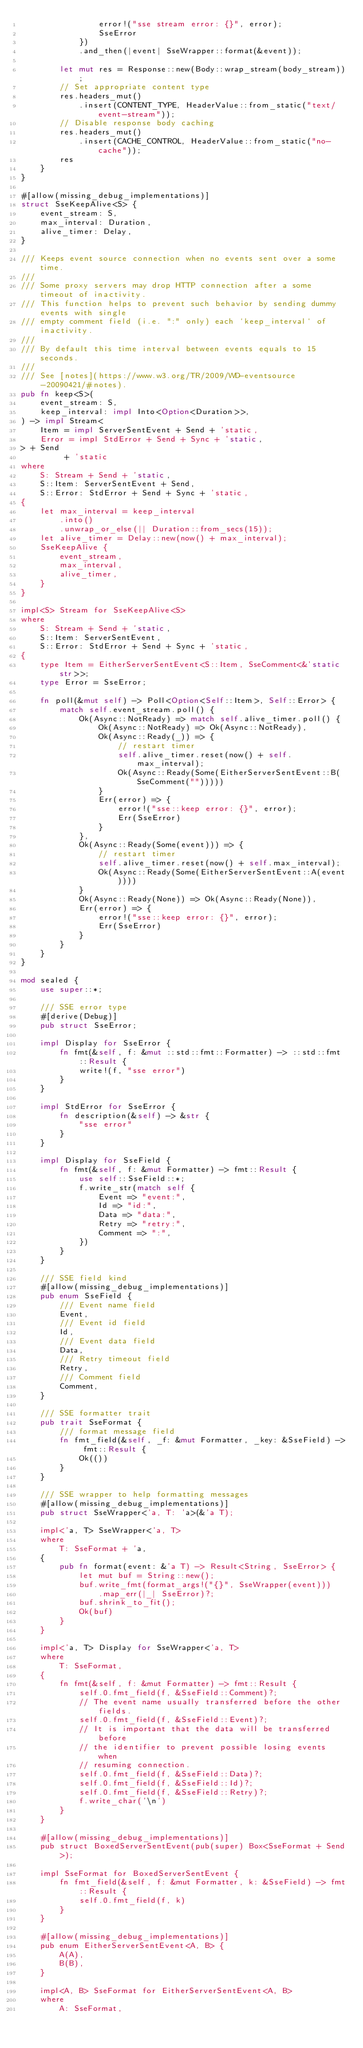Convert code to text. <code><loc_0><loc_0><loc_500><loc_500><_Rust_>                error!("sse stream error: {}", error);
                SseError
            })
            .and_then(|event| SseWrapper::format(&event));

        let mut res = Response::new(Body::wrap_stream(body_stream));
        // Set appropriate content type
        res.headers_mut()
            .insert(CONTENT_TYPE, HeaderValue::from_static("text/event-stream"));
        // Disable response body caching
        res.headers_mut()
            .insert(CACHE_CONTROL, HeaderValue::from_static("no-cache"));
        res
    }
}

#[allow(missing_debug_implementations)]
struct SseKeepAlive<S> {
    event_stream: S,
    max_interval: Duration,
    alive_timer: Delay,
}

/// Keeps event source connection when no events sent over a some time.
///
/// Some proxy servers may drop HTTP connection after a some timeout of inactivity.
/// This function helps to prevent such behavior by sending dummy events with single
/// empty comment field (i.e. ":" only) each `keep_interval` of inactivity.
///
/// By default this time interval between events equals to 15 seconds.
///
/// See [notes](https://www.w3.org/TR/2009/WD-eventsource-20090421/#notes).
pub fn keep<S>(
    event_stream: S,
    keep_interval: impl Into<Option<Duration>>,
) -> impl Stream<
    Item = impl ServerSentEvent + Send + 'static,
    Error = impl StdError + Send + Sync + 'static,
> + Send
         + 'static
where
    S: Stream + Send + 'static,
    S::Item: ServerSentEvent + Send,
    S::Error: StdError + Send + Sync + 'static,
{
    let max_interval = keep_interval
        .into()
        .unwrap_or_else(|| Duration::from_secs(15));
    let alive_timer = Delay::new(now() + max_interval);
    SseKeepAlive {
        event_stream,
        max_interval,
        alive_timer,
    }
}

impl<S> Stream for SseKeepAlive<S>
where
    S: Stream + Send + 'static,
    S::Item: ServerSentEvent,
    S::Error: StdError + Send + Sync + 'static,
{
    type Item = EitherServerSentEvent<S::Item, SseComment<&'static str>>;
    type Error = SseError;

    fn poll(&mut self) -> Poll<Option<Self::Item>, Self::Error> {
        match self.event_stream.poll() {
            Ok(Async::NotReady) => match self.alive_timer.poll() {
                Ok(Async::NotReady) => Ok(Async::NotReady),
                Ok(Async::Ready(_)) => {
                    // restart timer
                    self.alive_timer.reset(now() + self.max_interval);
                    Ok(Async::Ready(Some(EitherServerSentEvent::B(SseComment("")))))
                }
                Err(error) => {
                    error!("sse::keep error: {}", error);
                    Err(SseError)
                }
            },
            Ok(Async::Ready(Some(event))) => {
                // restart timer
                self.alive_timer.reset(now() + self.max_interval);
                Ok(Async::Ready(Some(EitherServerSentEvent::A(event))))
            }
            Ok(Async::Ready(None)) => Ok(Async::Ready(None)),
            Err(error) => {
                error!("sse::keep error: {}", error);
                Err(SseError)
            }
        }
    }
}

mod sealed {
    use super::*;

    /// SSE error type
    #[derive(Debug)]
    pub struct SseError;

    impl Display for SseError {
        fn fmt(&self, f: &mut ::std::fmt::Formatter) -> ::std::fmt::Result {
            write!(f, "sse error")
        }
    }

    impl StdError for SseError {
        fn description(&self) -> &str {
            "sse error"
        }
    }

    impl Display for SseField {
        fn fmt(&self, f: &mut Formatter) -> fmt::Result {
            use self::SseField::*;
            f.write_str(match self {
                Event => "event:",
                Id => "id:",
                Data => "data:",
                Retry => "retry:",
                Comment => ":",
            })
        }
    }

    /// SSE field kind
    #[allow(missing_debug_implementations)]
    pub enum SseField {
        /// Event name field
        Event,
        /// Event id field
        Id,
        /// Event data field
        Data,
        /// Retry timeout field
        Retry,
        /// Comment field
        Comment,
    }

    /// SSE formatter trait
    pub trait SseFormat {
        /// format message field
        fn fmt_field(&self, _f: &mut Formatter, _key: &SseField) -> fmt::Result {
            Ok(())
        }
    }

    /// SSE wrapper to help formatting messages
    #[allow(missing_debug_implementations)]
    pub struct SseWrapper<'a, T: 'a>(&'a T);

    impl<'a, T> SseWrapper<'a, T>
    where
        T: SseFormat + 'a,
    {
        pub fn format(event: &'a T) -> Result<String, SseError> {
            let mut buf = String::new();
            buf.write_fmt(format_args!("{}", SseWrapper(event)))
                .map_err(|_| SseError)?;
            buf.shrink_to_fit();
            Ok(buf)
        }
    }

    impl<'a, T> Display for SseWrapper<'a, T>
    where
        T: SseFormat,
    {
        fn fmt(&self, f: &mut Formatter) -> fmt::Result {
            self.0.fmt_field(f, &SseField::Comment)?;
            // The event name usually transferred before the other fields.
            self.0.fmt_field(f, &SseField::Event)?;
            // It is important that the data will be transferred before
            // the identifier to prevent possible losing events when
            // resuming connection.
            self.0.fmt_field(f, &SseField::Data)?;
            self.0.fmt_field(f, &SseField::Id)?;
            self.0.fmt_field(f, &SseField::Retry)?;
            f.write_char('\n')
        }
    }

    #[allow(missing_debug_implementations)]
    pub struct BoxedServerSentEvent(pub(super) Box<SseFormat + Send>);

    impl SseFormat for BoxedServerSentEvent {
        fn fmt_field(&self, f: &mut Formatter, k: &SseField) -> fmt::Result {
            self.0.fmt_field(f, k)
        }
    }

    #[allow(missing_debug_implementations)]
    pub enum EitherServerSentEvent<A, B> {
        A(A),
        B(B),
    }

    impl<A, B> SseFormat for EitherServerSentEvent<A, B>
    where
        A: SseFormat,</code> 